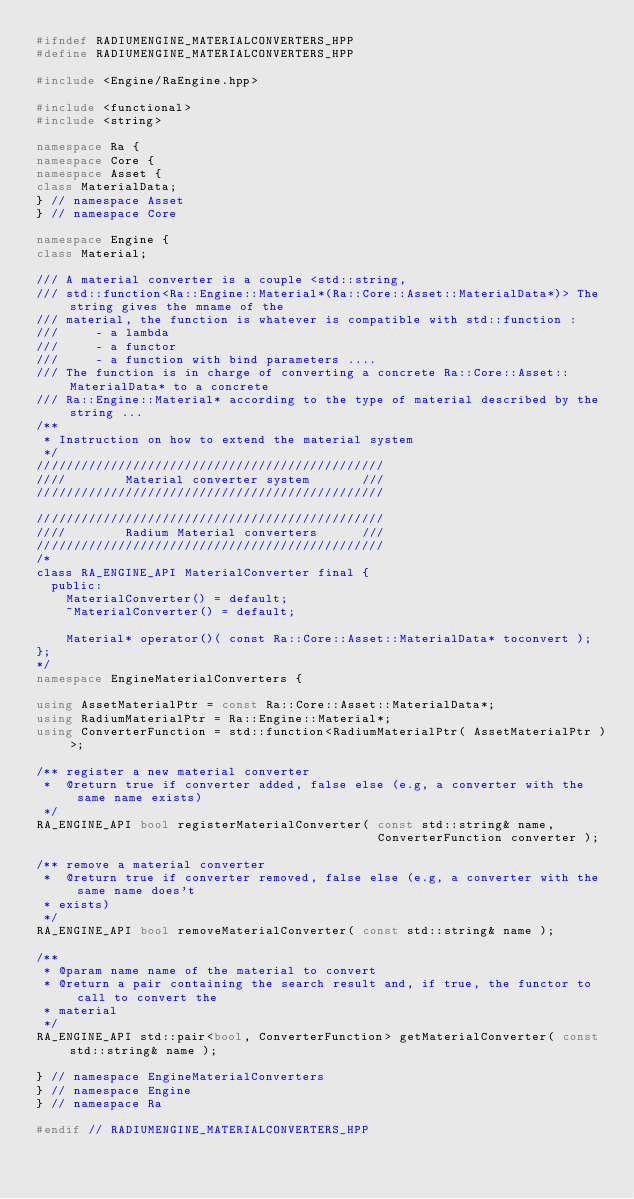Convert code to text. <code><loc_0><loc_0><loc_500><loc_500><_C++_>#ifndef RADIUMENGINE_MATERIALCONVERTERS_HPP
#define RADIUMENGINE_MATERIALCONVERTERS_HPP

#include <Engine/RaEngine.hpp>

#include <functional>
#include <string>

namespace Ra {
namespace Core {
namespace Asset {
class MaterialData;
} // namespace Asset
} // namespace Core

namespace Engine {
class Material;

/// A material converter is a couple <std::string,
/// std::function<Ra::Engine::Material*(Ra::Core::Asset::MaterialData*)> The string gives the mname of the
/// material, the function is whatever is compatible with std::function :
///     - a lambda
///     - a functor
///     - a function with bind parameters ....
/// The function is in charge of converting a concrete Ra::Core::Asset::MaterialData* to a concrete
/// Ra::Engine::Material* according to the type of material described by the string ...
/**
 * Instruction on how to extend the material system
 */
///////////////////////////////////////////////
////        Material converter system       ///
///////////////////////////////////////////////

///////////////////////////////////////////////
////        Radium Material converters      ///
///////////////////////////////////////////////
/*
class RA_ENGINE_API MaterialConverter final {
  public:
    MaterialConverter() = default;
    ~MaterialConverter() = default;

    Material* operator()( const Ra::Core::Asset::MaterialData* toconvert );
};
*/
namespace EngineMaterialConverters {

using AssetMaterialPtr = const Ra::Core::Asset::MaterialData*;
using RadiumMaterialPtr = Ra::Engine::Material*;
using ConverterFunction = std::function<RadiumMaterialPtr( AssetMaterialPtr )>;

/** register a new material converter
 *  @return true if converter added, false else (e.g, a converter with the same name exists)
 */
RA_ENGINE_API bool registerMaterialConverter( const std::string& name,
                                              ConverterFunction converter );

/** remove a material converter
 *  @return true if converter removed, false else (e.g, a converter with the same name does't
 * exists)
 */
RA_ENGINE_API bool removeMaterialConverter( const std::string& name );

/**
 * @param name name of the material to convert
 * @return a pair containing the search result and, if true, the functor to call to convert the
 * material
 */
RA_ENGINE_API std::pair<bool, ConverterFunction> getMaterialConverter( const std::string& name );

} // namespace EngineMaterialConverters
} // namespace Engine
} // namespace Ra

#endif // RADIUMENGINE_MATERIALCONVERTERS_HPP
</code> 